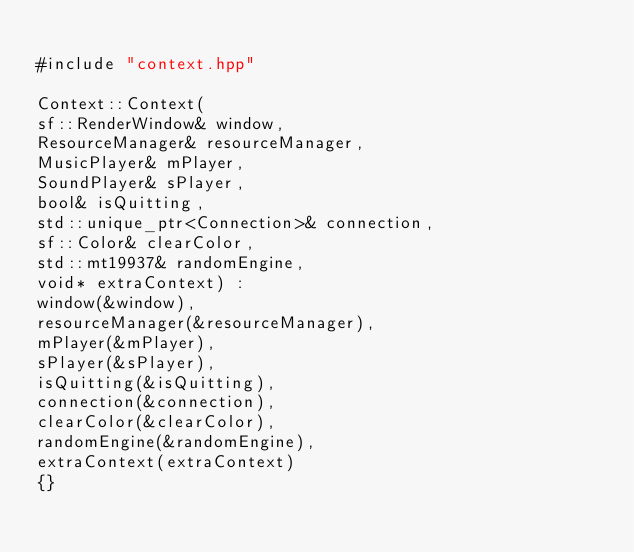<code> <loc_0><loc_0><loc_500><loc_500><_C++_>
#include "context.hpp"

Context::Context(
sf::RenderWindow& window,
ResourceManager& resourceManager,
MusicPlayer& mPlayer,
SoundPlayer& sPlayer,
bool& isQuitting,
std::unique_ptr<Connection>& connection,
sf::Color& clearColor,
std::mt19937& randomEngine,
void* extraContext) :
window(&window),
resourceManager(&resourceManager),
mPlayer(&mPlayer),
sPlayer(&sPlayer),
isQuitting(&isQuitting),
connection(&connection),
clearColor(&clearColor),
randomEngine(&randomEngine),
extraContext(extraContext)
{}
</code> 